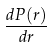Convert formula to latex. <formula><loc_0><loc_0><loc_500><loc_500>\frac { d P ( r ) } { d r }</formula> 